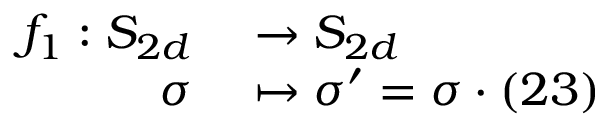Convert formula to latex. <formula><loc_0><loc_0><loc_500><loc_500>\begin{array} { r l } { f _ { 1 } \colon S _ { 2 d } } & \to S _ { 2 d } } \\ { \sigma } & \mapsto \sigma ^ { \prime } = \sigma \cdot ( 2 3 ) } \end{array}</formula> 